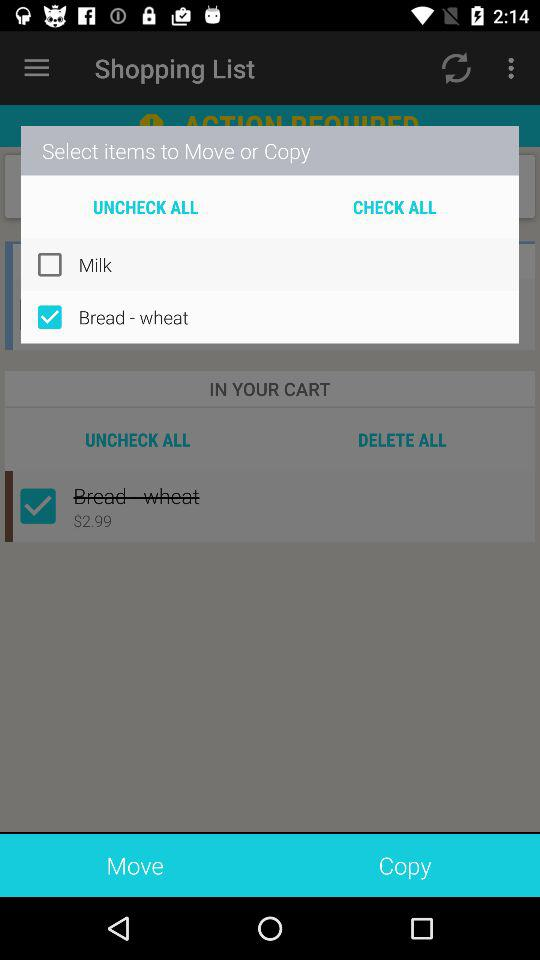What is the selected item? The selected item is "Bread - wheat". 